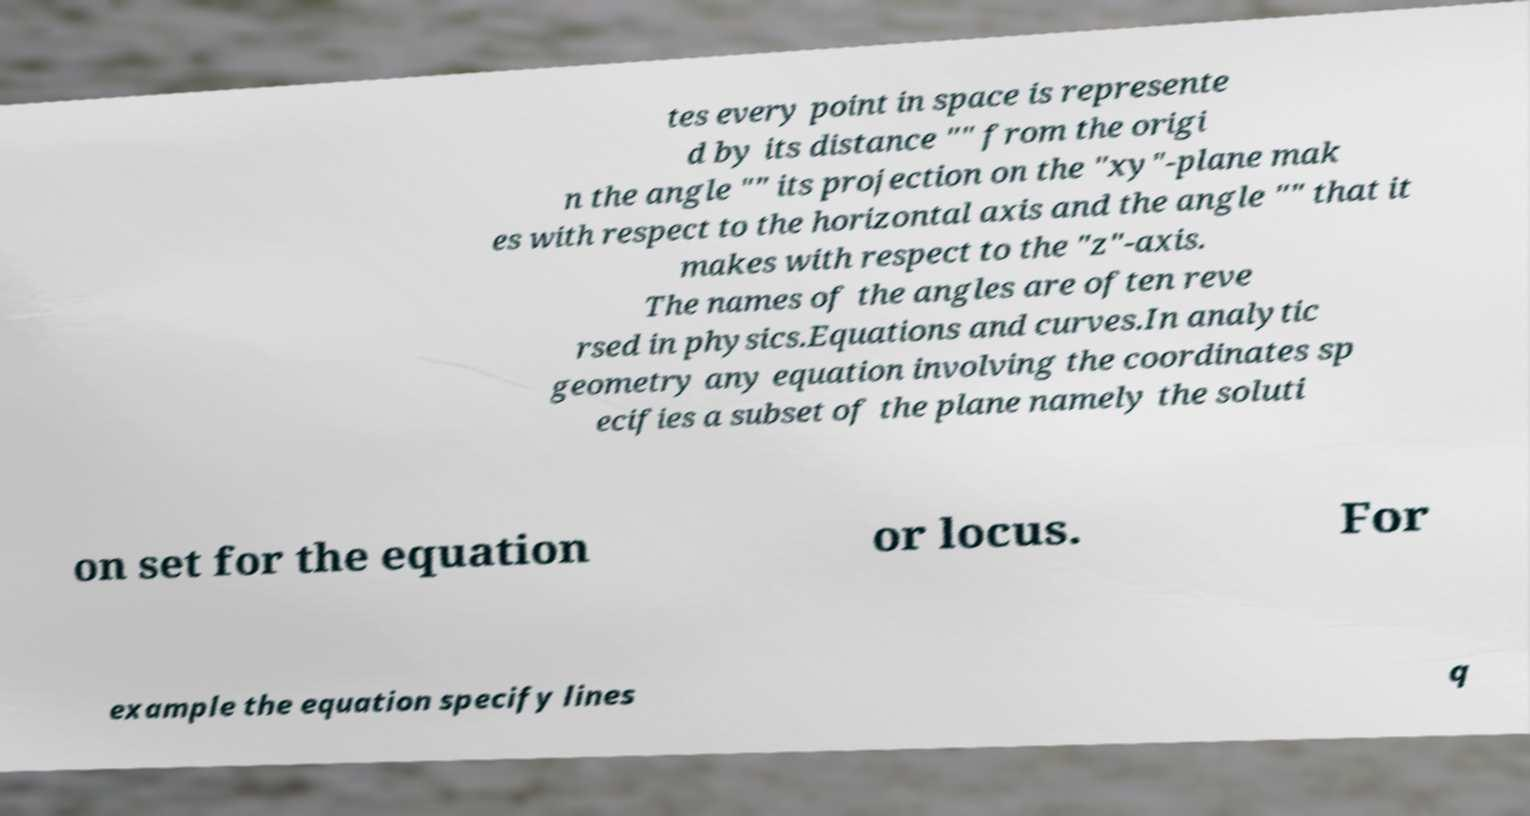There's text embedded in this image that I need extracted. Can you transcribe it verbatim? tes every point in space is represente d by its distance "" from the origi n the angle "" its projection on the "xy"-plane mak es with respect to the horizontal axis and the angle "" that it makes with respect to the "z"-axis. The names of the angles are often reve rsed in physics.Equations and curves.In analytic geometry any equation involving the coordinates sp ecifies a subset of the plane namely the soluti on set for the equation or locus. For example the equation specify lines q 